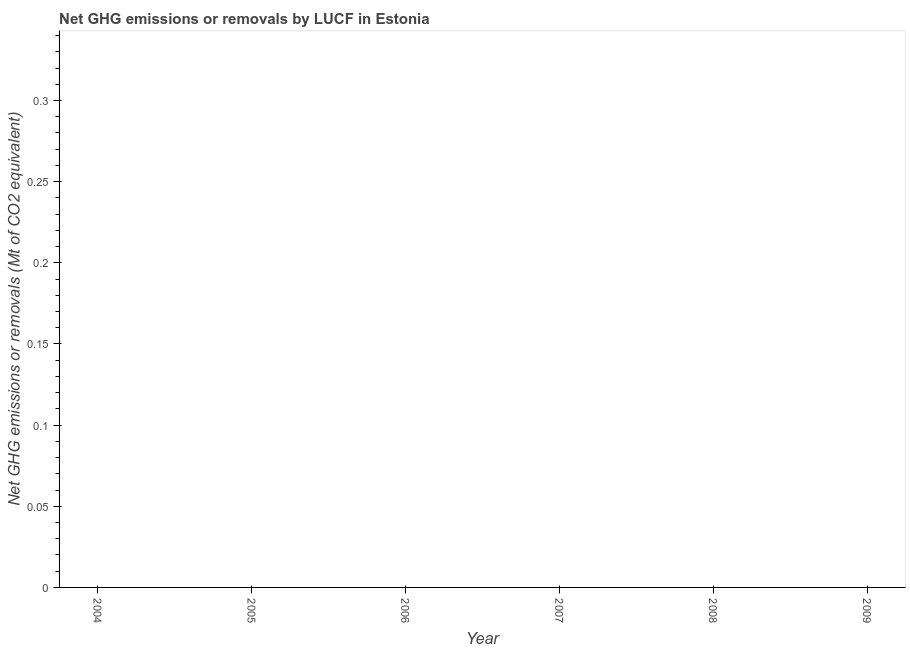Across all years, what is the minimum ghg net emissions or removals?
Keep it short and to the point. 0. What is the sum of the ghg net emissions or removals?
Give a very brief answer. 0. In how many years, is the ghg net emissions or removals greater than 0.14 Mt?
Provide a succinct answer. 0. Does the ghg net emissions or removals monotonically increase over the years?
Keep it short and to the point. No. How many years are there in the graph?
Your answer should be compact. 6. Does the graph contain any zero values?
Offer a very short reply. Yes. What is the title of the graph?
Ensure brevity in your answer.  Net GHG emissions or removals by LUCF in Estonia. What is the label or title of the X-axis?
Offer a terse response. Year. What is the label or title of the Y-axis?
Provide a short and direct response. Net GHG emissions or removals (Mt of CO2 equivalent). What is the Net GHG emissions or removals (Mt of CO2 equivalent) in 2005?
Keep it short and to the point. 0. What is the Net GHG emissions or removals (Mt of CO2 equivalent) in 2006?
Ensure brevity in your answer.  0. What is the Net GHG emissions or removals (Mt of CO2 equivalent) in 2007?
Give a very brief answer. 0. What is the Net GHG emissions or removals (Mt of CO2 equivalent) in 2009?
Keep it short and to the point. 0. 